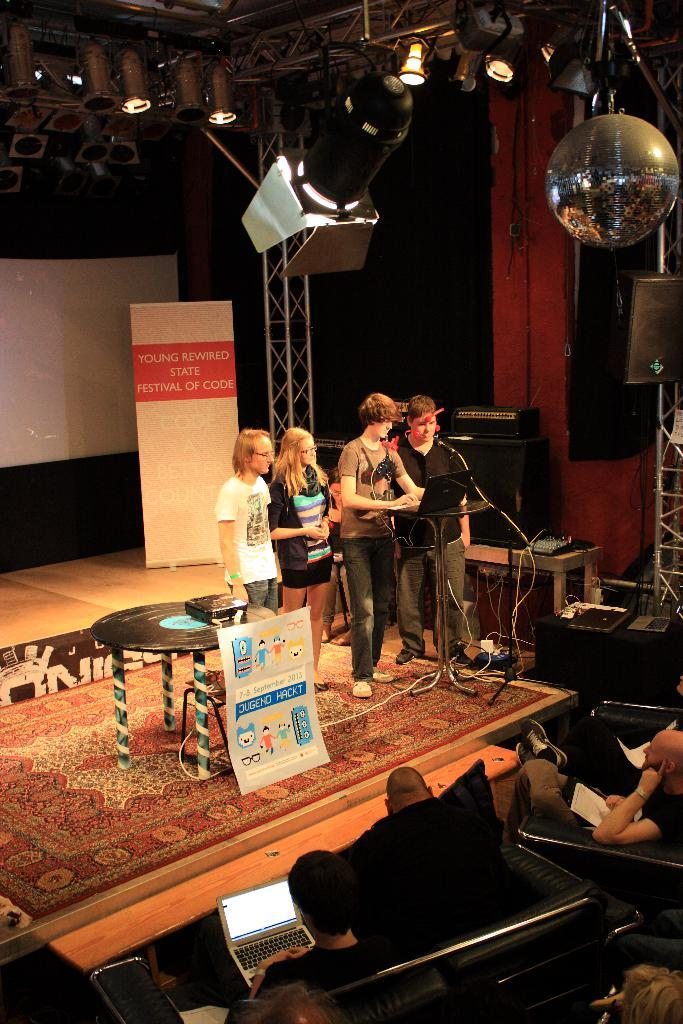How many people are in the center of the image? There are four persons standing in the middle of the image. What are the four persons looking at? The four persons are looking at a laptop. What can be seen at the top of the image? There are lights at the top of the image. What type of seating is present at the bottom of the image? There are people sitting on sofa chairs at the bottom of the image. What type of degree is being awarded to the person on the left in the image? There is no indication of a degree or any award ceremony in the image. 